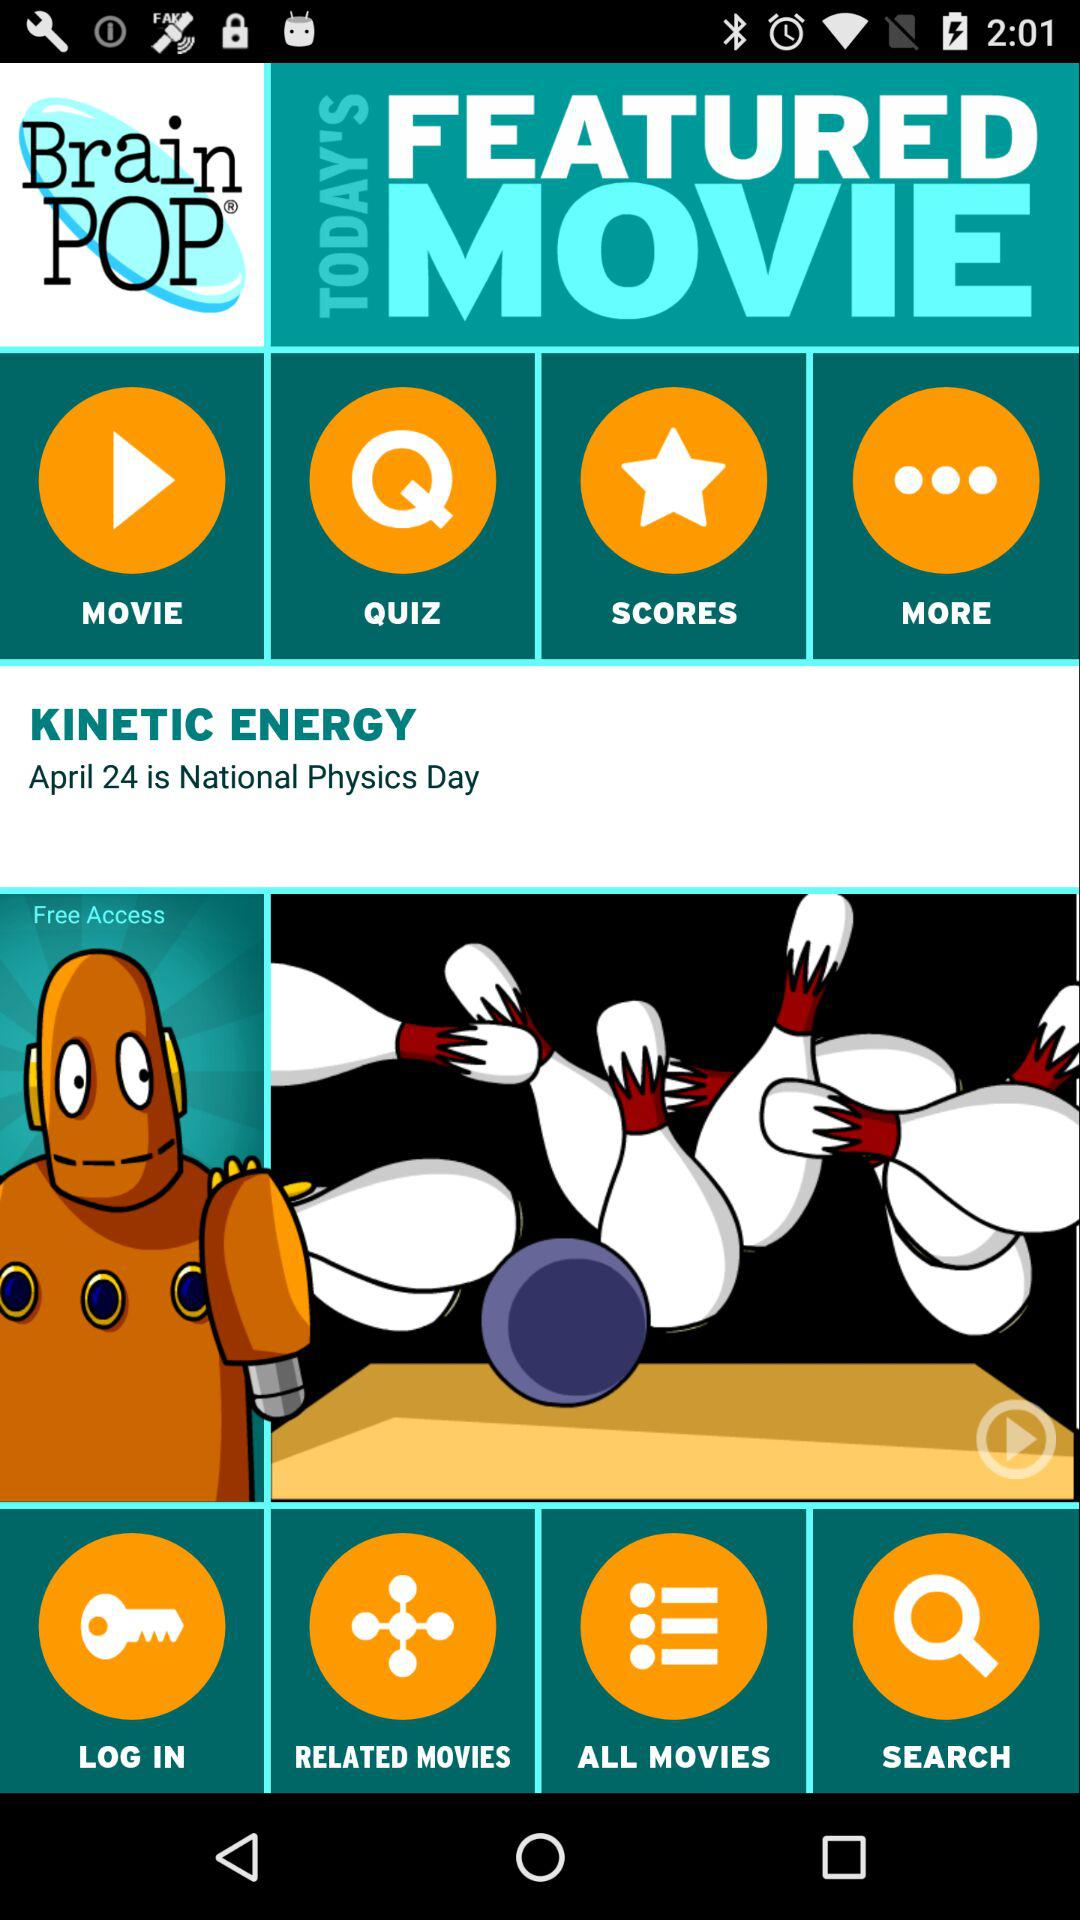How many questions are in the quiz?
When the provided information is insufficient, respond with <no answer>. <no answer> 